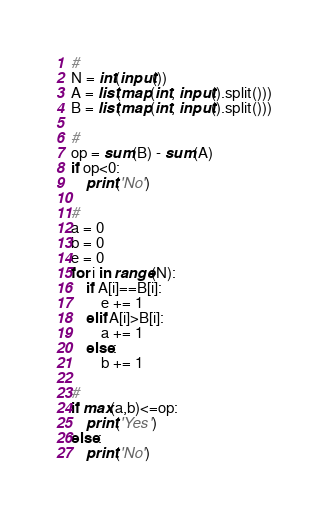Convert code to text. <code><loc_0><loc_0><loc_500><loc_500><_Python_>#
N = int(input())
A = list(map(int, input().split()))
B = list(map(int, input().split()))

#
op = sum(B) - sum(A)
if op<0:
    print('No')

#
a = 0
b = 0
e = 0
for i in range(N):
    if A[i]==B[i]:
        e += 1
    elif A[i]>B[i]:
        a += 1
    else:
        b += 1

#
if max(a,b)<=op:
    print('Yes')
else:
    print('No')
</code> 